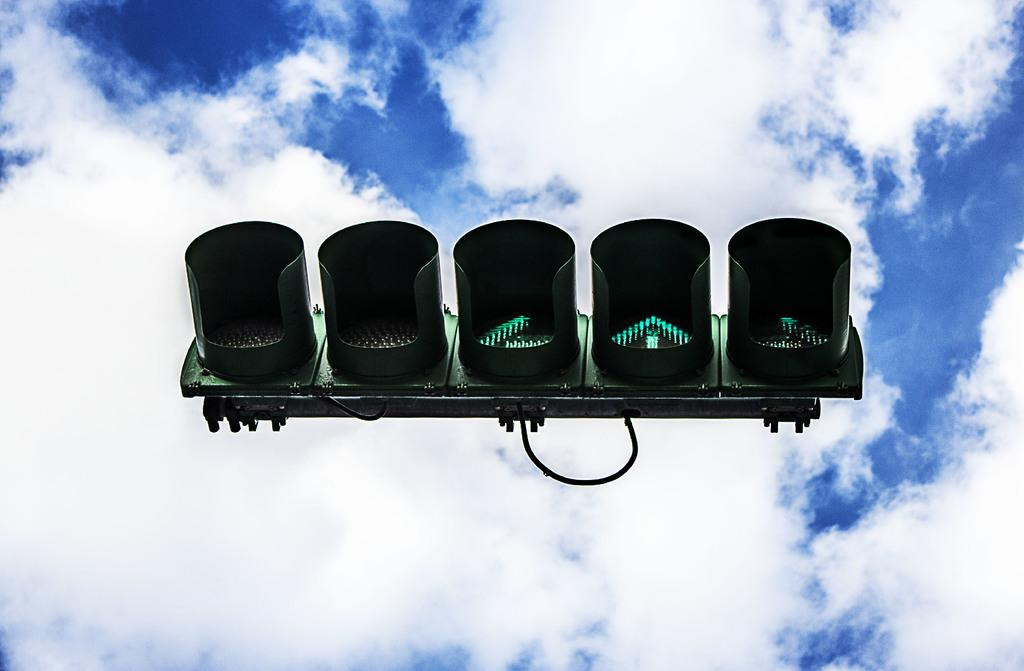What is the main object in the sky in the image? There is a signal board in the sky in the image. How many women are present in the image? There is no information about women in the image, as the only fact provided is about a signal board in the sky. 